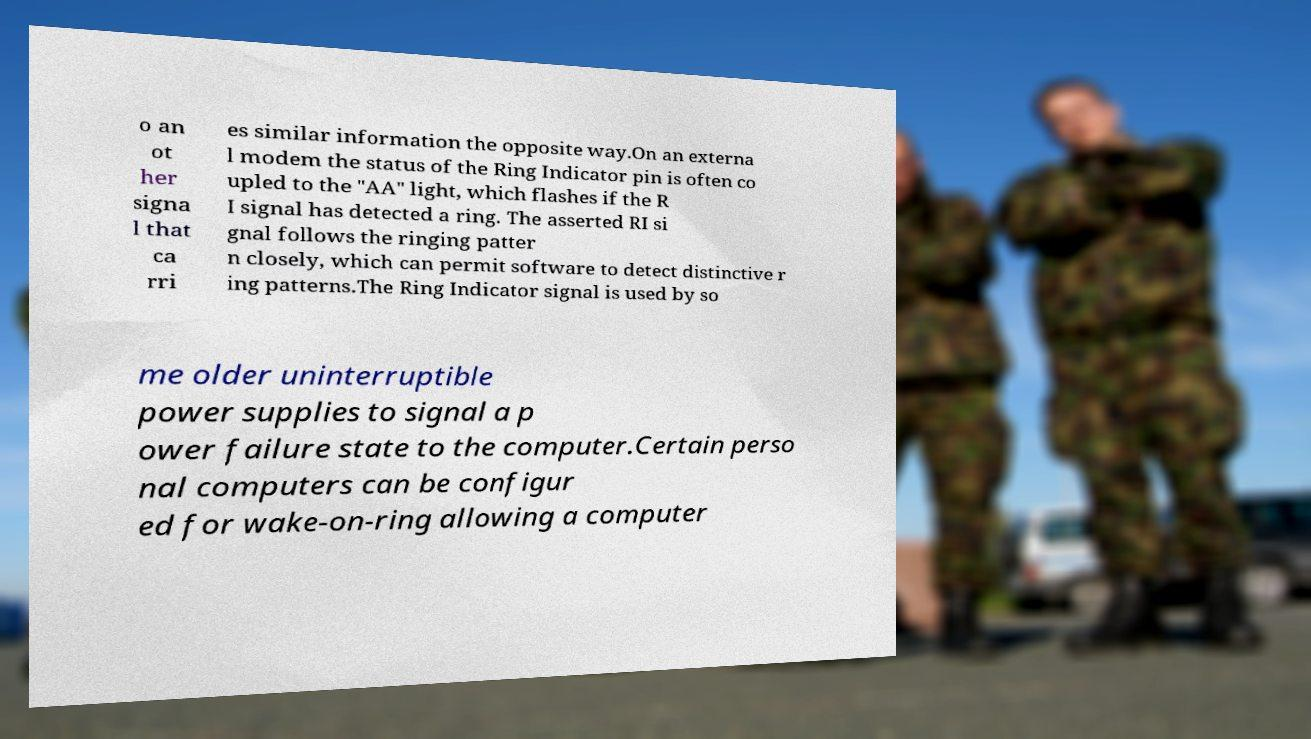Please identify and transcribe the text found in this image. o an ot her signa l that ca rri es similar information the opposite way.On an externa l modem the status of the Ring Indicator pin is often co upled to the "AA" light, which flashes if the R I signal has detected a ring. The asserted RI si gnal follows the ringing patter n closely, which can permit software to detect distinctive r ing patterns.The Ring Indicator signal is used by so me older uninterruptible power supplies to signal a p ower failure state to the computer.Certain perso nal computers can be configur ed for wake-on-ring allowing a computer 